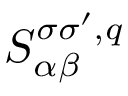<formula> <loc_0><loc_0><loc_500><loc_500>S _ { \alpha \beta } ^ { \sigma \sigma ^ { \prime } , q }</formula> 